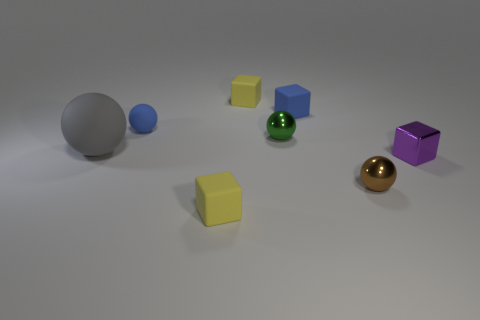What kind of lighting is used in the image, and from where is it coming? The lighting in the image appears soft and diffused, creating gentle shadows. It seems to be coming from the upper left side based on the direction of the shadows being cast towards the right. 